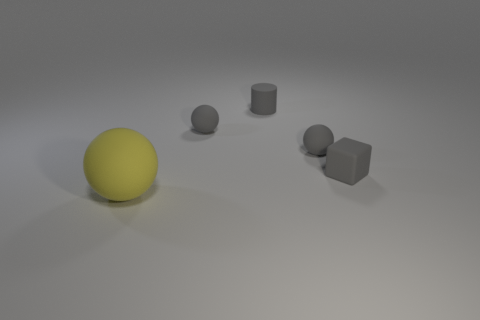How many other things are there of the same material as the big yellow thing?
Provide a succinct answer. 4. There is a small ball that is to the right of the small matte cylinder; is it the same color as the block to the right of the gray rubber cylinder?
Your answer should be very brief. Yes. What number of balls are either big yellow matte objects or gray objects?
Offer a very short reply. 3. Are there an equal number of small rubber blocks on the left side of the gray matte cube and tiny gray matte balls?
Your answer should be very brief. No. There is a gray thing that is right of the tiny gray sphere in front of the gray object left of the tiny rubber cylinder; what is it made of?
Your answer should be compact. Rubber. What is the material of the tiny block that is the same color as the small cylinder?
Provide a short and direct response. Rubber. What number of things are either small objects behind the small gray matte block or tiny blue metallic cylinders?
Provide a short and direct response. 3. What number of things are either small gray cubes or balls that are behind the big yellow rubber thing?
Provide a succinct answer. 3. What number of small matte cylinders are in front of the matte thing that is to the left of the gray sphere left of the cylinder?
Your response must be concise. 0. There is a block that is the same size as the matte cylinder; what material is it?
Offer a very short reply. Rubber. 